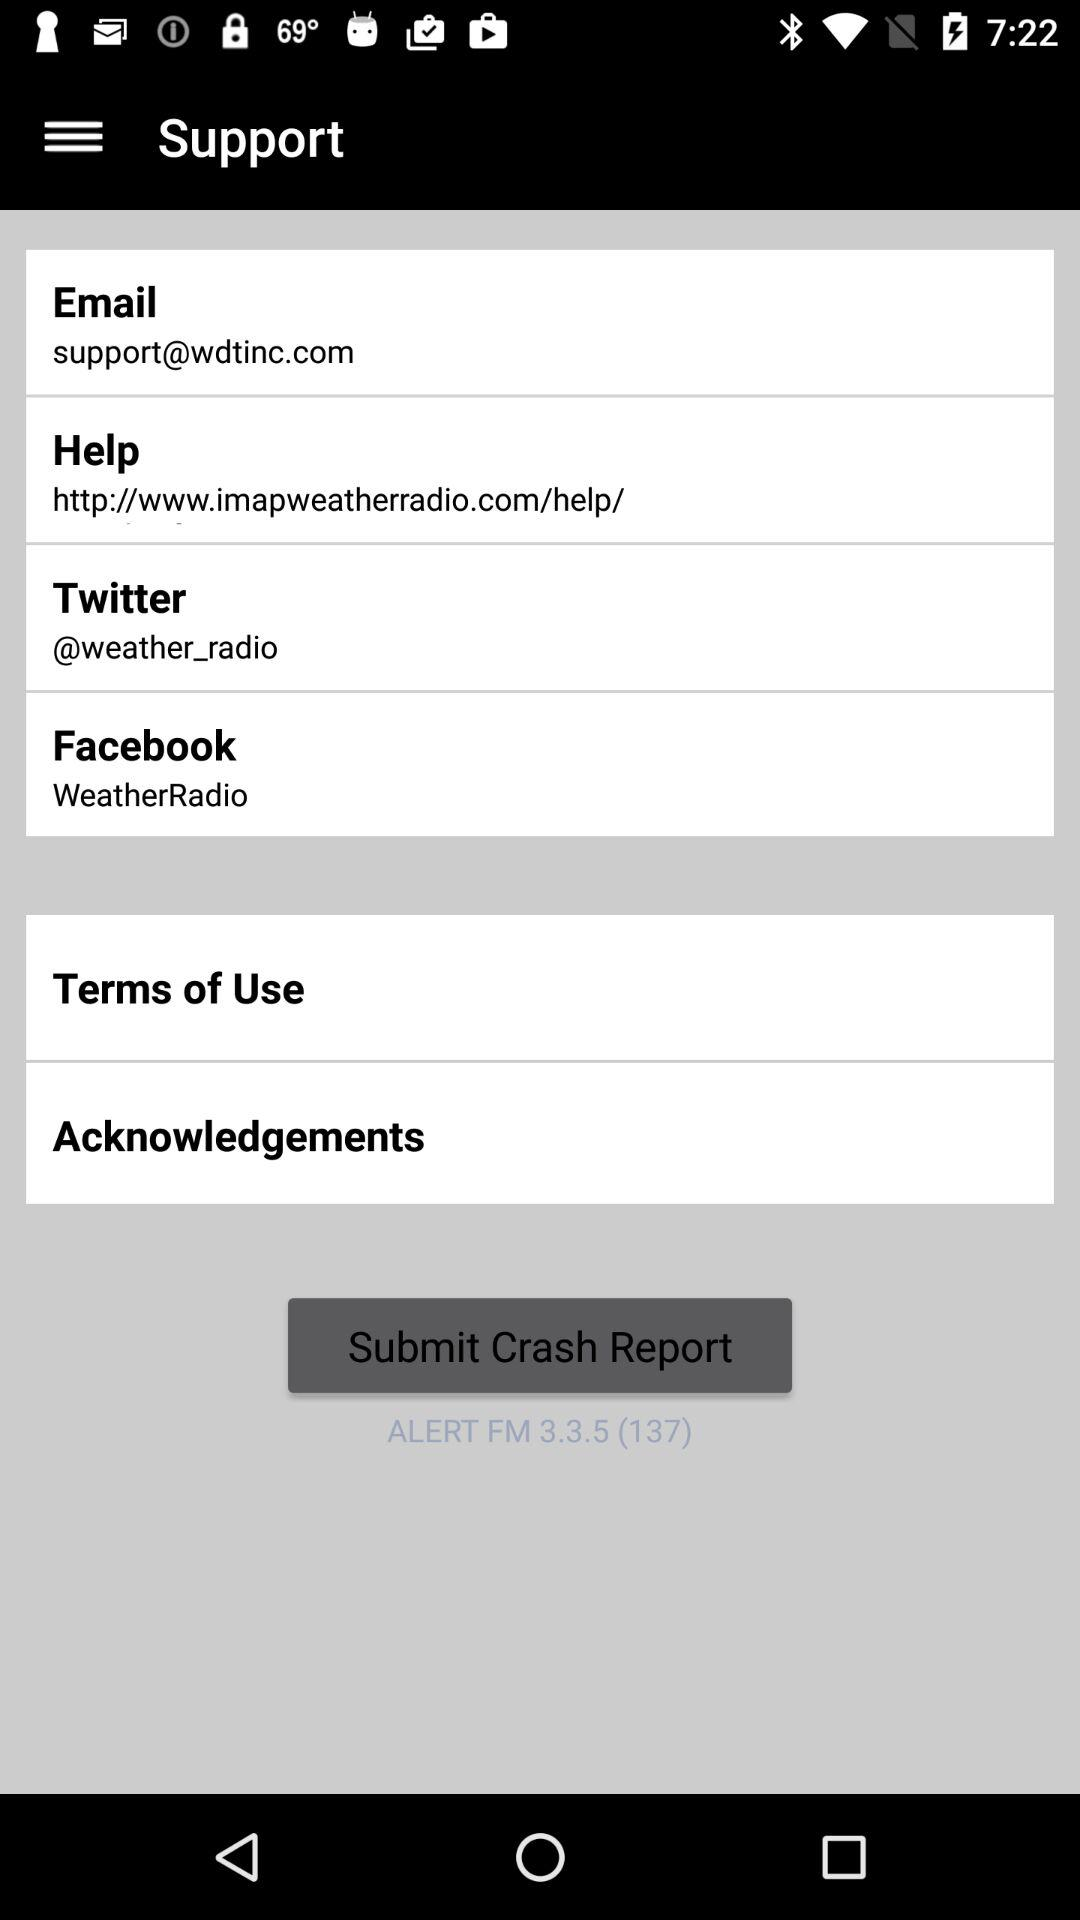What is the email address for support? The email address for support is support@wdtinc.com. 